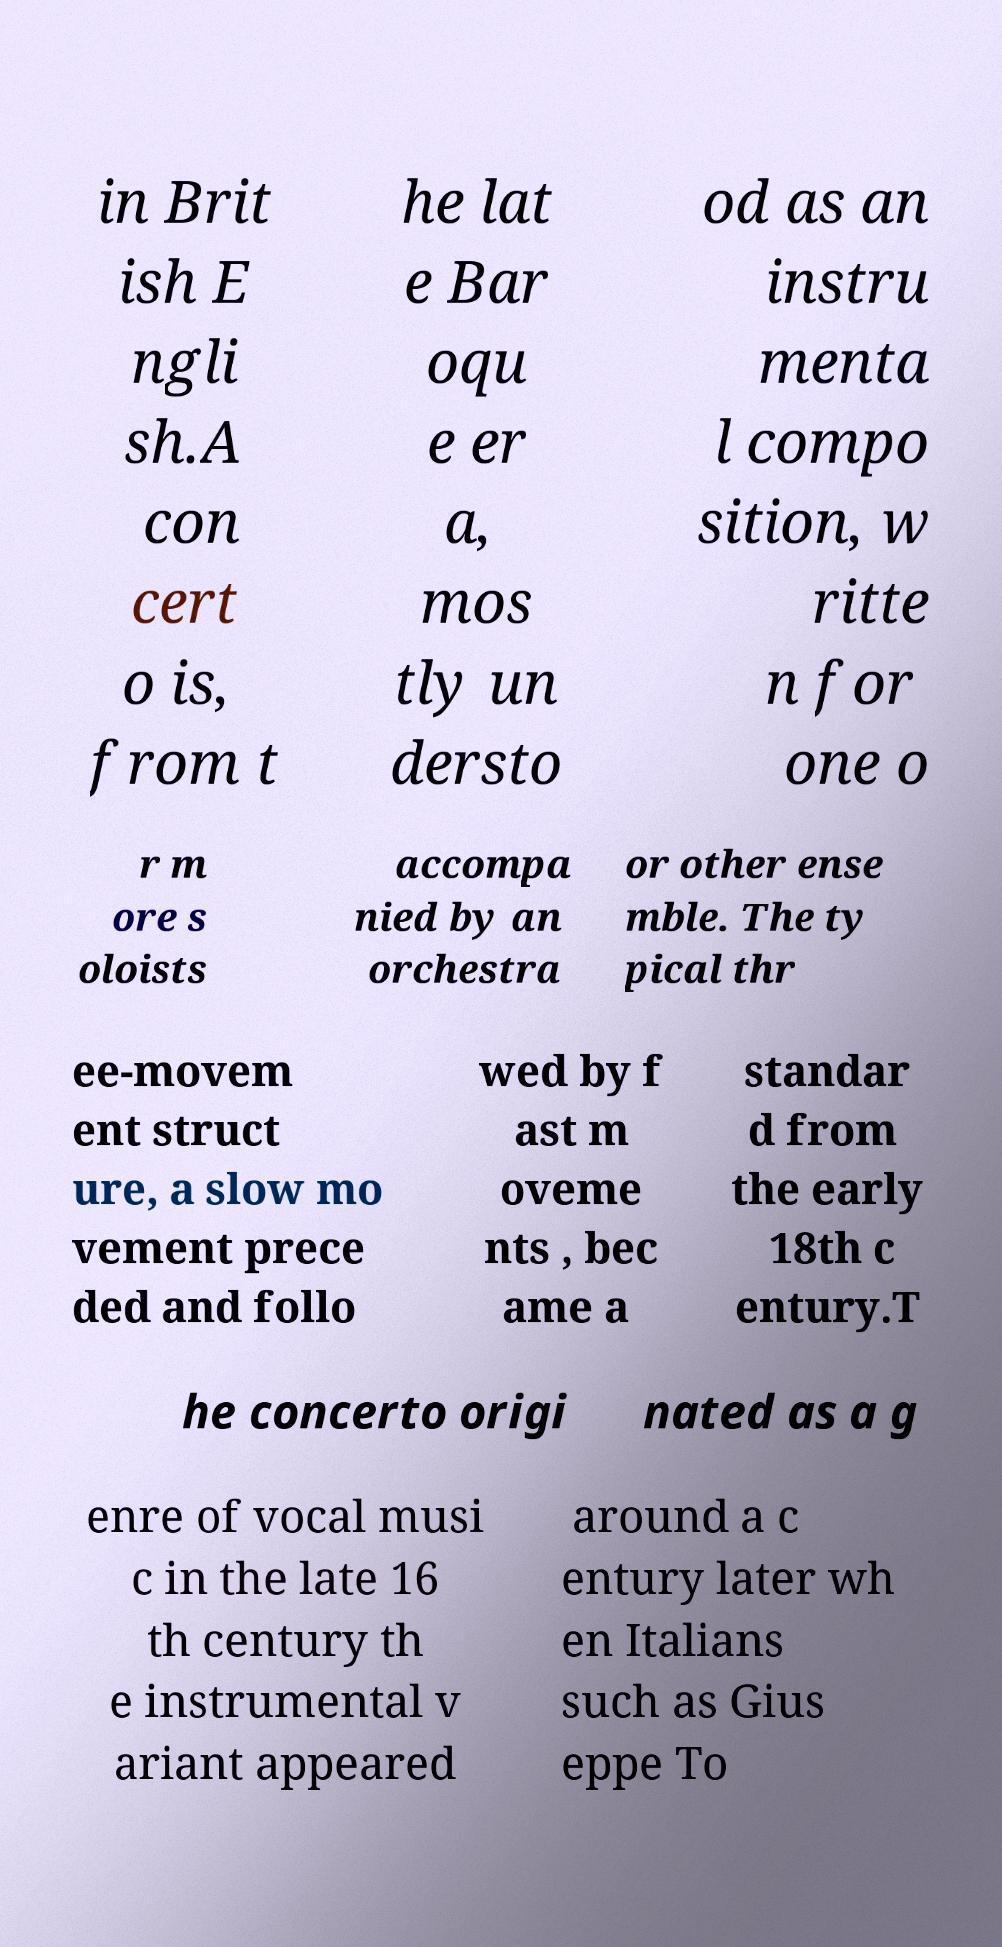Could you extract and type out the text from this image? in Brit ish E ngli sh.A con cert o is, from t he lat e Bar oqu e er a, mos tly un dersto od as an instru menta l compo sition, w ritte n for one o r m ore s oloists accompa nied by an orchestra or other ense mble. The ty pical thr ee-movem ent struct ure, a slow mo vement prece ded and follo wed by f ast m oveme nts , bec ame a standar d from the early 18th c entury.T he concerto origi nated as a g enre of vocal musi c in the late 16 th century th e instrumental v ariant appeared around a c entury later wh en Italians such as Gius eppe To 